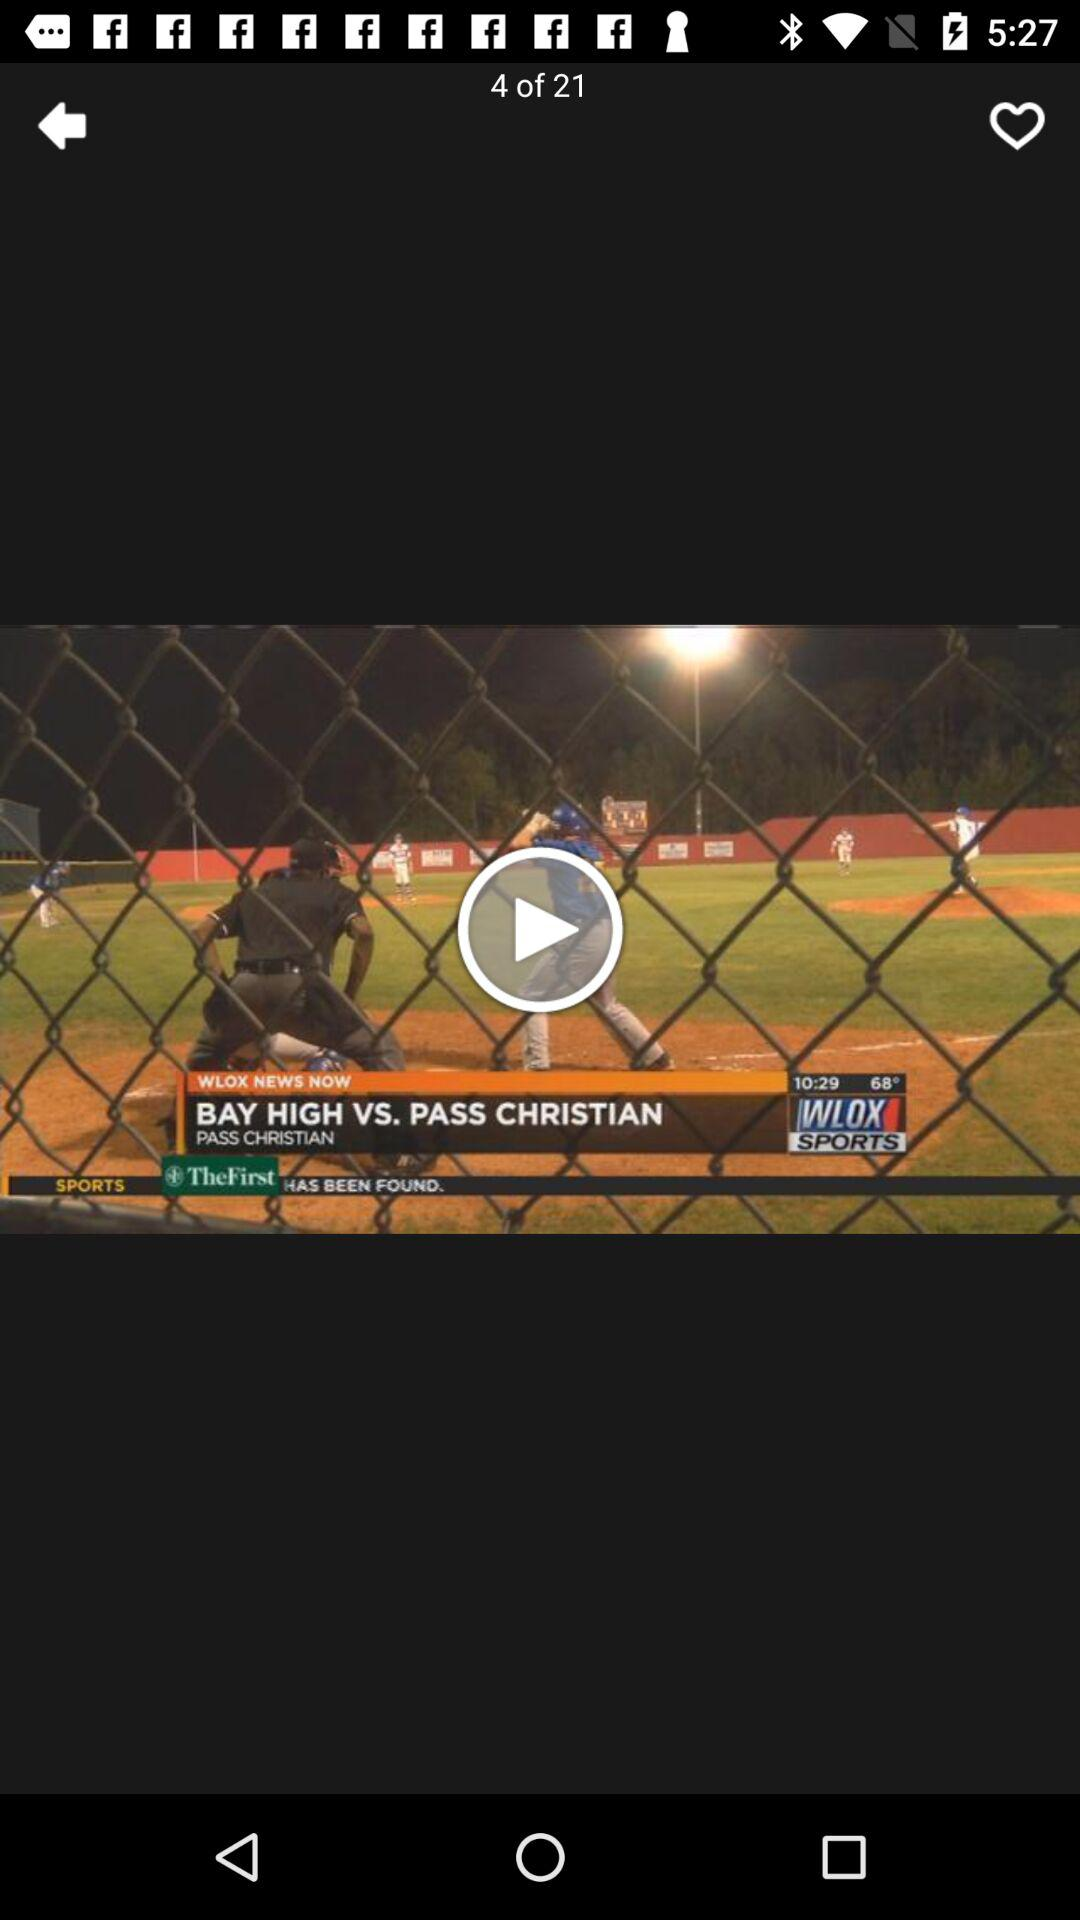When was the video uploaded?
When the provided information is insufficient, respond with <no answer>. <no answer> 